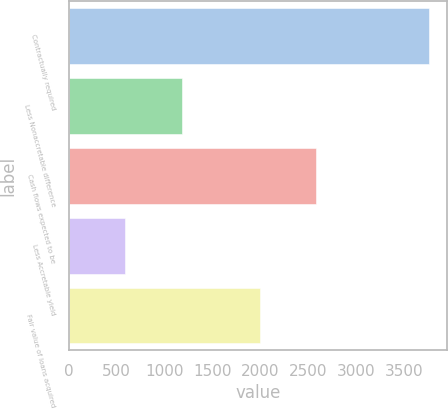Convert chart to OTSL. <chart><loc_0><loc_0><loc_500><loc_500><bar_chart><fcel>Contractually required<fcel>Less Nonaccretable difference<fcel>Cash flows expected to be<fcel>Less Accretable yield<fcel>Fair value of loans acquired<nl><fcel>3769<fcel>1184<fcel>2585<fcel>587<fcel>1998<nl></chart> 